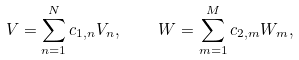<formula> <loc_0><loc_0><loc_500><loc_500>V = \sum _ { n = 1 } ^ { N } c _ { 1 , n } V _ { n } , \quad W = \sum _ { m = 1 } ^ { M } c _ { 2 , m } W _ { m } ,</formula> 